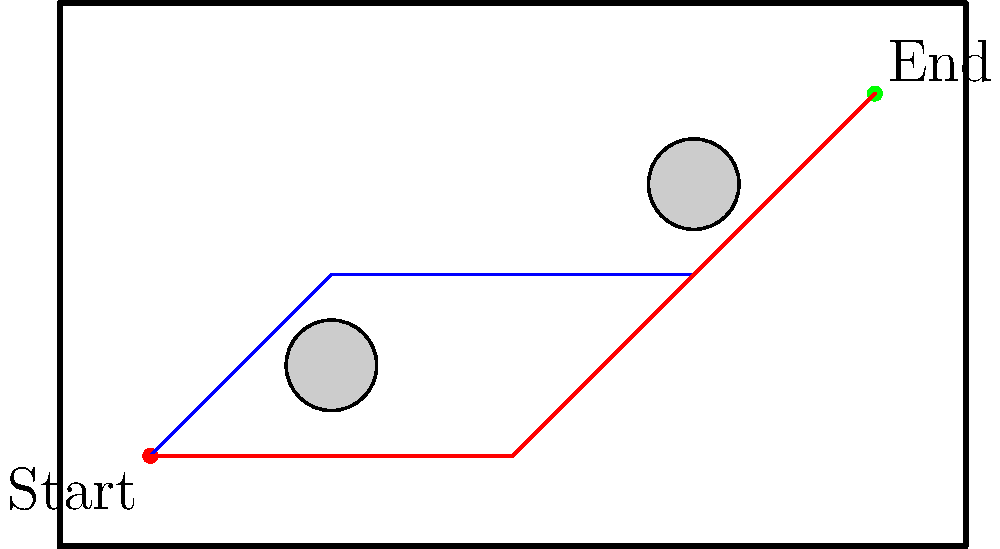In a polo field represented by a $10 \times 6$ unit rectangle, you need to guide your horse from the start point $(1,1)$ to the end point $(9,5)$. There are two circular obstacles with radius $0.5$ units centered at $(3,2)$ and $(7,4)$. Two possible paths are shown: a blue path passing between the obstacles and a red path skirting the bottom of the field. Which path is shorter, and by how much? Assume the horse can only move in straight lines between turns. To solve this problem, we need to calculate the lengths of both paths and compare them:

1. Blue path:
   - Segment 1: $(1,1)$ to $(3,3)$
   - Segment 2: $(3,3)$ to $(7,3)$
   - Segment 3: $(7,3)$ to $(9,5)$

2. Red path:
   - Segment 1: $(1,1)$ to $(5,1)$
   - Segment 2: $(5,1)$ to $(9,5)$

Let's calculate the length of each segment using the distance formula:
$d = \sqrt{(x_2-x_1)^2 + (y_2-y_1)^2}$

Blue path:
- Segment 1: $\sqrt{(3-1)^2 + (3-1)^2} = \sqrt{8} = 2\sqrt{2}$
- Segment 2: $\sqrt{(7-3)^2 + (3-3)^2} = 4$
- Segment 3: $\sqrt{(9-7)^2 + (5-3)^2} = \sqrt{8} = 2\sqrt{2}$
Total blue path length: $2\sqrt{2} + 4 + 2\sqrt{2} = 4 + 4\sqrt{2} \approx 9.66$ units

Red path:
- Segment 1: $\sqrt{(5-1)^2 + (1-1)^2} = 4$
- Segment 2: $\sqrt{(9-5)^2 + (5-1)^2} = \sqrt{32} = 4\sqrt{2}$
Total red path length: $4 + 4\sqrt{2} \approx 9.66$ units

Both paths have the same length: $4 + 4\sqrt{2}$ units.
Answer: Both paths are equal in length: $4 + 4\sqrt{2}$ units. 